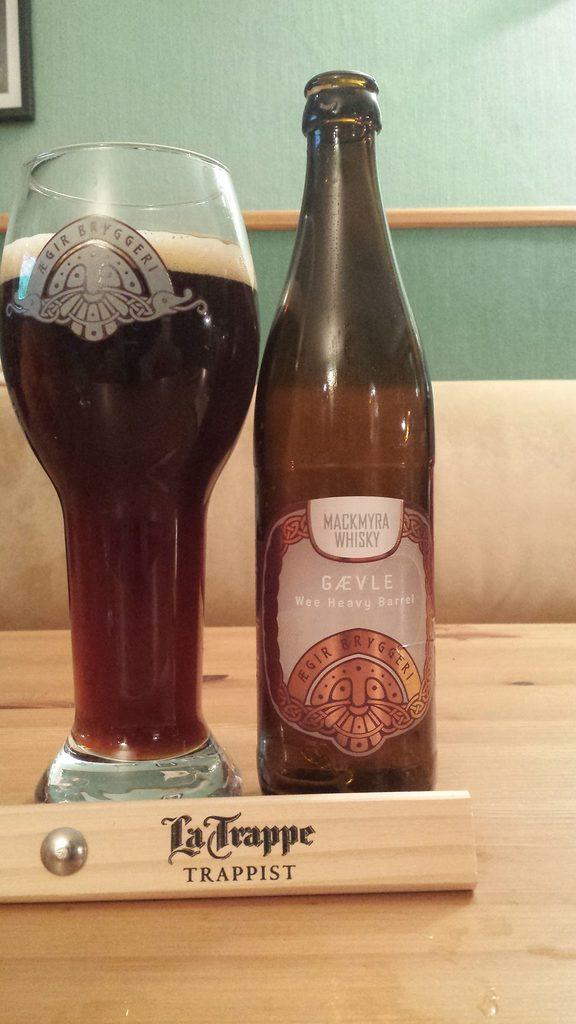Provide a one-sentence caption for the provided image. A bottle and glass sit behind a piece of wood that says La Trappe. 